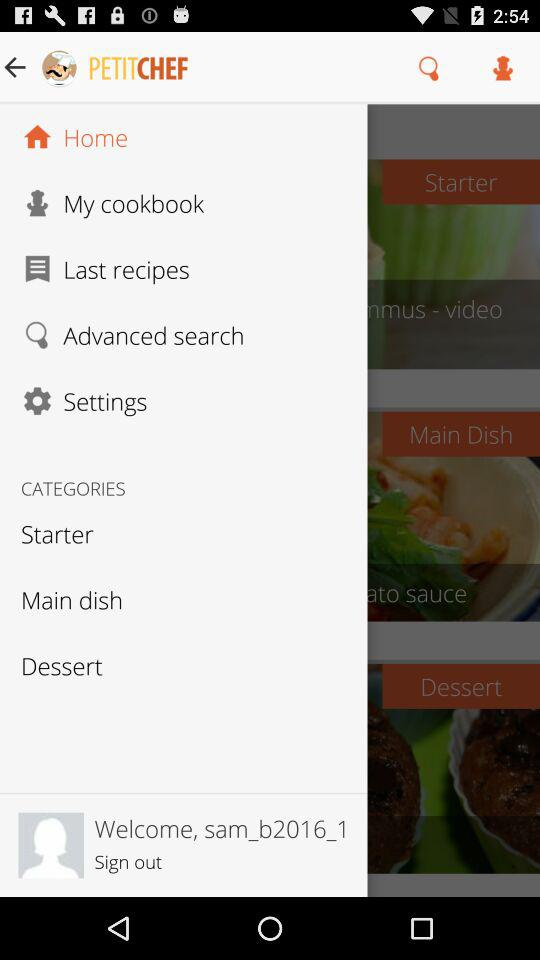What is the app name? The app name is "PetitChef, cooking and recipes". 